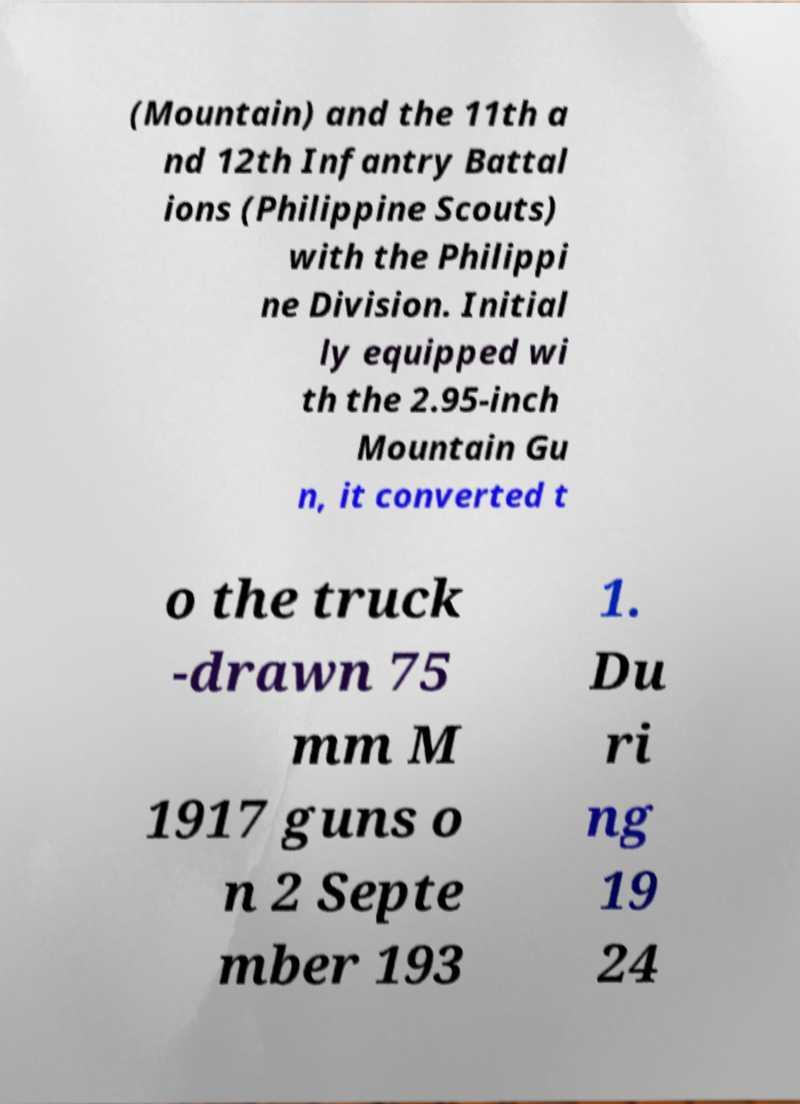Could you assist in decoding the text presented in this image and type it out clearly? (Mountain) and the 11th a nd 12th Infantry Battal ions (Philippine Scouts) with the Philippi ne Division. Initial ly equipped wi th the 2.95-inch Mountain Gu n, it converted t o the truck -drawn 75 mm M 1917 guns o n 2 Septe mber 193 1. Du ri ng 19 24 